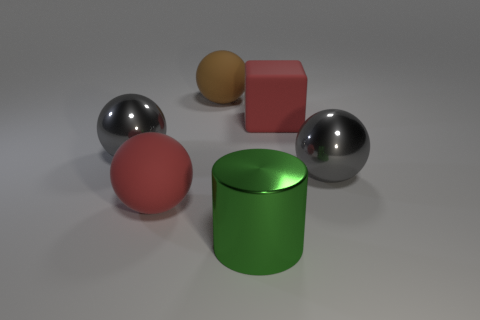There is another large matte object that is the same shape as the large brown rubber object; what color is it?
Ensure brevity in your answer.  Red. What number of big things are either metallic spheres or green cylinders?
Provide a succinct answer. 3. Are there any matte balls of the same color as the large rubber cube?
Keep it short and to the point. Yes. There is a large object that is the same color as the large block; what is its shape?
Your response must be concise. Sphere. What number of big cubes are right of the rubber sphere in front of the big rubber block?
Make the answer very short. 1. What number of green cylinders have the same material as the big red ball?
Make the answer very short. 0. There is a red cube; are there any metallic objects in front of it?
Provide a succinct answer. Yes. What is the color of the block that is the same size as the red rubber ball?
Your response must be concise. Red. How many objects are either balls to the right of the cylinder or large metallic spheres?
Offer a terse response. 2. What is the size of the rubber object that is both in front of the brown object and left of the big green metallic object?
Keep it short and to the point. Large. 